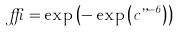Convert formula to latex. <formula><loc_0><loc_0><loc_500><loc_500>\delta = \exp \left ( - \exp \left ( c \varepsilon ^ { - 6 } \right ) \right )</formula> 